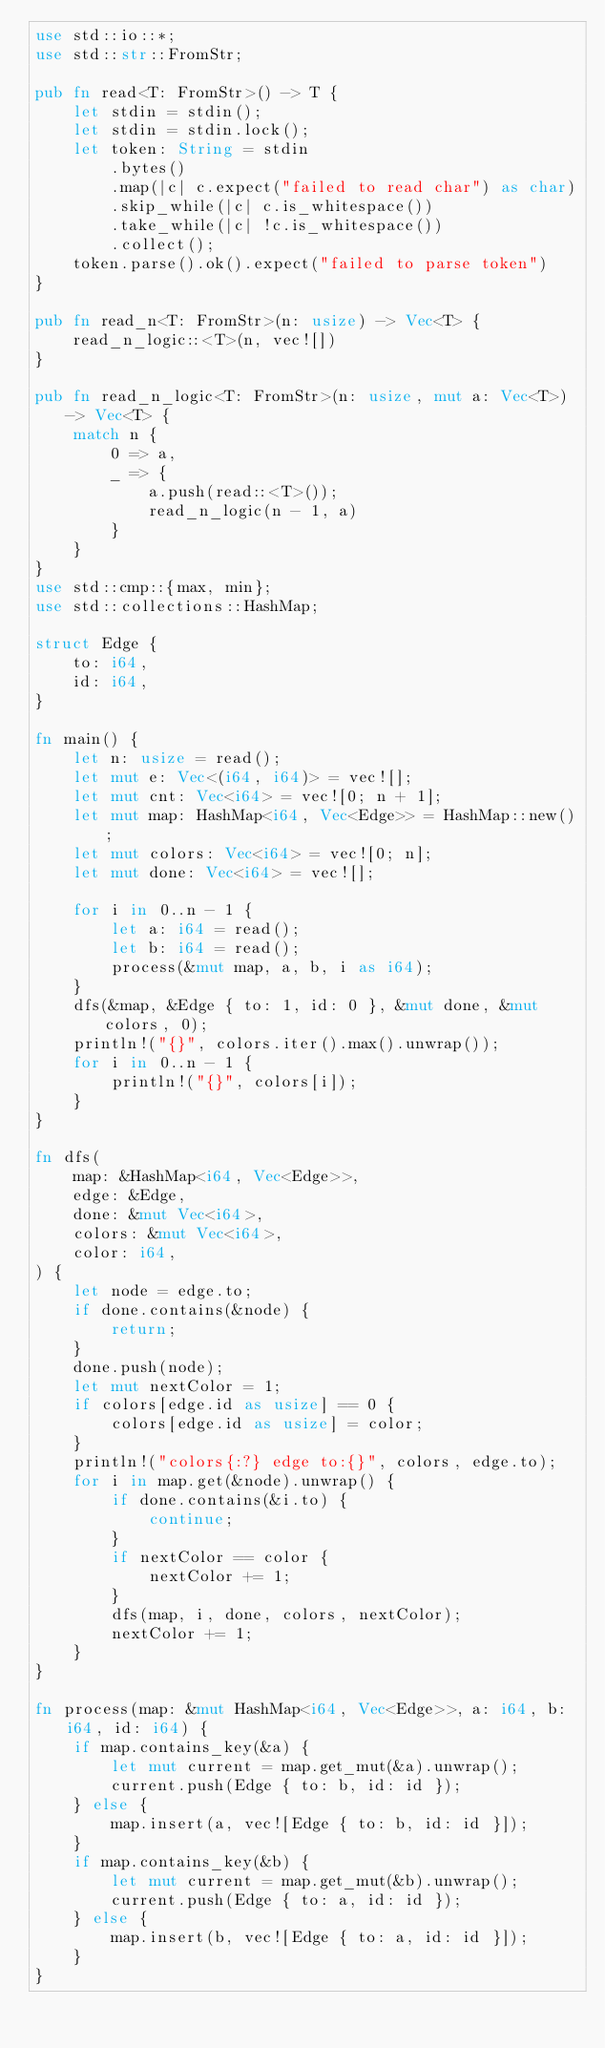Convert code to text. <code><loc_0><loc_0><loc_500><loc_500><_Rust_>use std::io::*;
use std::str::FromStr;

pub fn read<T: FromStr>() -> T {
    let stdin = stdin();
    let stdin = stdin.lock();
    let token: String = stdin
        .bytes()
        .map(|c| c.expect("failed to read char") as char)
        .skip_while(|c| c.is_whitespace())
        .take_while(|c| !c.is_whitespace())
        .collect();
    token.parse().ok().expect("failed to parse token")
}

pub fn read_n<T: FromStr>(n: usize) -> Vec<T> {
    read_n_logic::<T>(n, vec![])
}

pub fn read_n_logic<T: FromStr>(n: usize, mut a: Vec<T>) -> Vec<T> {
    match n {
        0 => a,
        _ => {
            a.push(read::<T>());
            read_n_logic(n - 1, a)
        }
    }
}
use std::cmp::{max, min};
use std::collections::HashMap;

struct Edge {
    to: i64,
    id: i64,
}

fn main() {
    let n: usize = read();
    let mut e: Vec<(i64, i64)> = vec![];
    let mut cnt: Vec<i64> = vec![0; n + 1];
    let mut map: HashMap<i64, Vec<Edge>> = HashMap::new();
    let mut colors: Vec<i64> = vec![0; n];
    let mut done: Vec<i64> = vec![];

    for i in 0..n - 1 {
        let a: i64 = read();
        let b: i64 = read();
        process(&mut map, a, b, i as i64);
    }
    dfs(&map, &Edge { to: 1, id: 0 }, &mut done, &mut colors, 0);
    println!("{}", colors.iter().max().unwrap());
    for i in 0..n - 1 {
        println!("{}", colors[i]);
    }
}

fn dfs(
    map: &HashMap<i64, Vec<Edge>>,
    edge: &Edge,
    done: &mut Vec<i64>,
    colors: &mut Vec<i64>,
    color: i64,
) {
    let node = edge.to;
    if done.contains(&node) {
        return;
    }
    done.push(node);
    let mut nextColor = 1;
    if colors[edge.id as usize] == 0 {
        colors[edge.id as usize] = color;
    }
    println!("colors{:?} edge to:{}", colors, edge.to);
    for i in map.get(&node).unwrap() {
        if done.contains(&i.to) {
            continue;
        }
        if nextColor == color {
            nextColor += 1;
        }
        dfs(map, i, done, colors, nextColor);
        nextColor += 1;
    }
}

fn process(map: &mut HashMap<i64, Vec<Edge>>, a: i64, b: i64, id: i64) {
    if map.contains_key(&a) {
        let mut current = map.get_mut(&a).unwrap();
        current.push(Edge { to: b, id: id });
    } else {
        map.insert(a, vec![Edge { to: b, id: id }]);
    }
    if map.contains_key(&b) {
        let mut current = map.get_mut(&b).unwrap();
        current.push(Edge { to: a, id: id });
    } else {
        map.insert(b, vec![Edge { to: a, id: id }]);
    }
}
</code> 